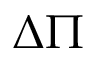<formula> <loc_0><loc_0><loc_500><loc_500>\Delta \Pi</formula> 